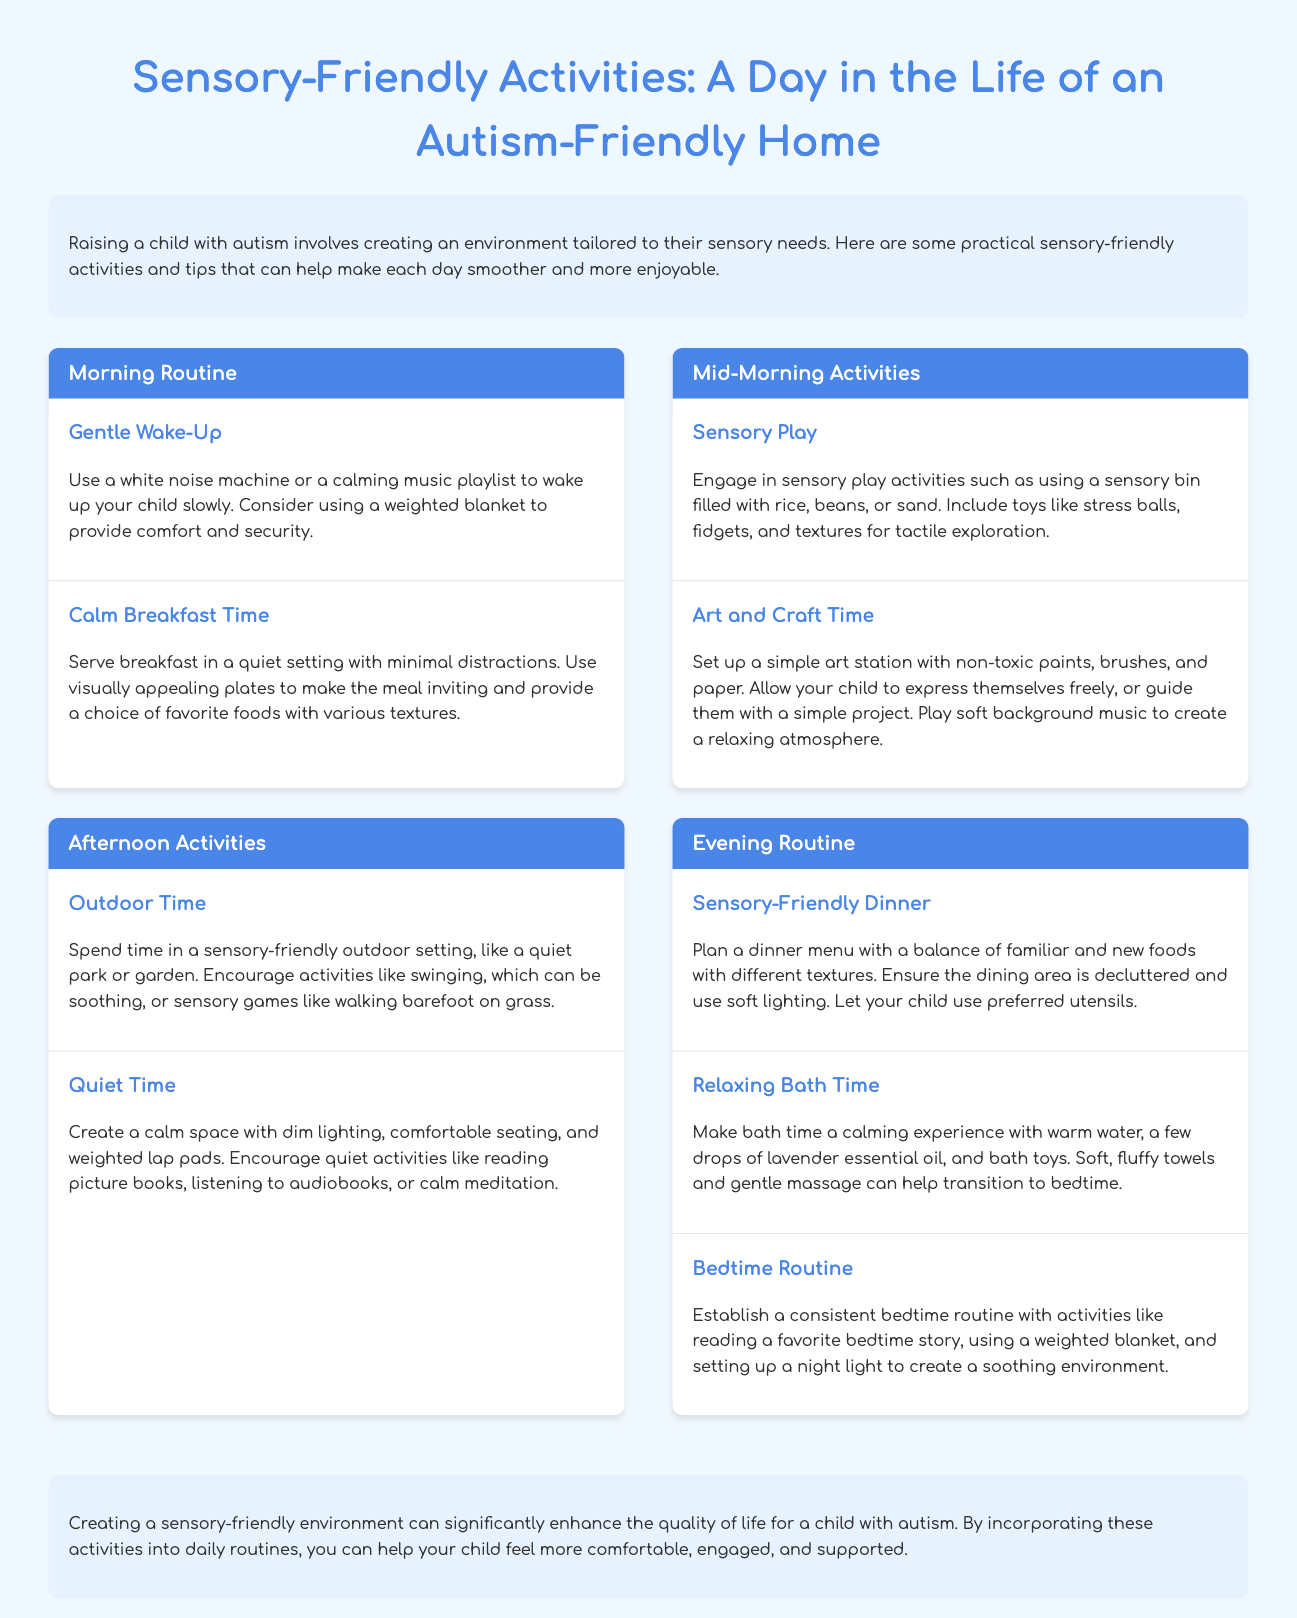What is the title of the infographic? The title of the infographic is prominently displayed at the top of the document.
Answer: Sensory-Friendly Activities: A Day in the Life of an Autism-Friendly Home How many activities are listed in the Evening Routine section? The Evening Routine section contains three activities as mentioned in the document.
Answer: 3 What type of environment is suggested for breakfast time? The breakfast time activity suggests serving breakfast in a setting with minimal distractions, as stated in the document.
Answer: Quiet Which activity involves a sensory bin? The sensory play activity includes a sensory bin, as mentioned in the Mid-Morning Activities section.
Answer: Sensory Play What calming scent is recommended for bath time? The document suggests using lavender essential oil to create a calming bath experience.
Answer: Lavender What kind of music should be played during the art and craft time? The art and craft time activity recommends playing soft background music to enhance relaxation.
Answer: Soft How many sections are there in the timeline of activities? The timeline of activities is divided into four sections, as referred to in the document.
Answer: 4 What is a suggested outdoor activity mentioned in the Afternoon Activities section? Walking barefoot on grass is recommended as a sensory-friendly outdoor activity in the document.
Answer: Walking barefoot on grass What is used in the bedtime routine to promote a soothing environment? The bedtime routine includes a weighted blanket as part of creating a soothing environment.
Answer: Weighted blanket 